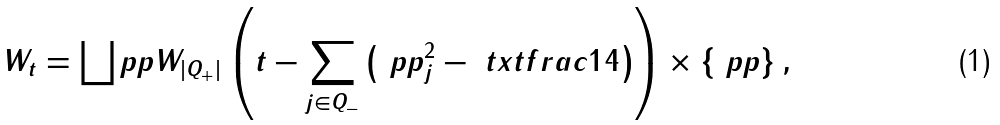<formula> <loc_0><loc_0><loc_500><loc_500>W _ { t } = \bigsqcup _ { \ } p p W _ { | Q _ { + } | } \left ( t - \sum _ { j \in Q _ { - } } \left ( \ p p _ { j } ^ { 2 } - \ t x t f r a c 1 4 \right ) \right ) \times \{ \ p p \} \, ,</formula> 